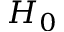<formula> <loc_0><loc_0><loc_500><loc_500>H _ { 0 }</formula> 